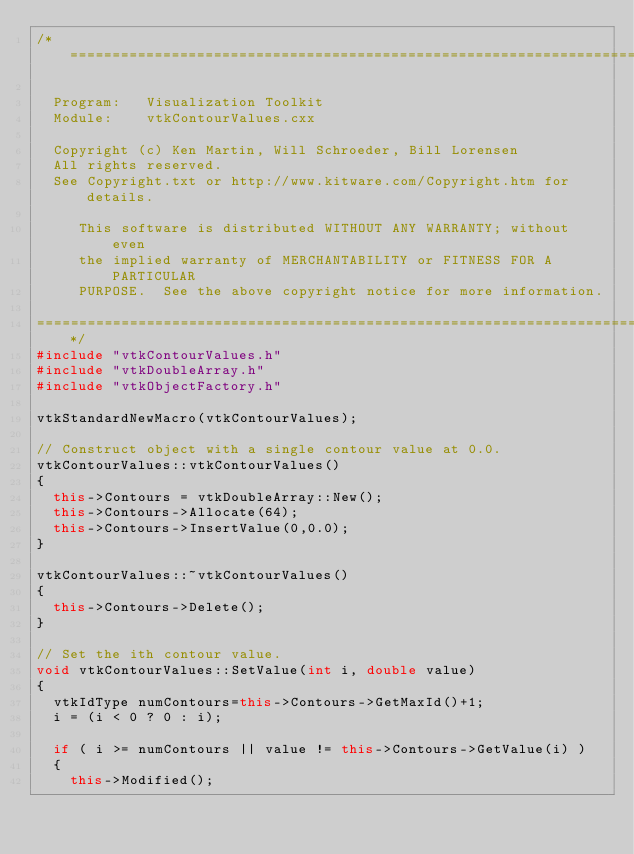Convert code to text. <code><loc_0><loc_0><loc_500><loc_500><_C++_>/*=========================================================================

  Program:   Visualization Toolkit
  Module:    vtkContourValues.cxx

  Copyright (c) Ken Martin, Will Schroeder, Bill Lorensen
  All rights reserved.
  See Copyright.txt or http://www.kitware.com/Copyright.htm for details.

     This software is distributed WITHOUT ANY WARRANTY; without even
     the implied warranty of MERCHANTABILITY or FITNESS FOR A PARTICULAR
     PURPOSE.  See the above copyright notice for more information.

=========================================================================*/
#include "vtkContourValues.h"
#include "vtkDoubleArray.h"
#include "vtkObjectFactory.h"

vtkStandardNewMacro(vtkContourValues);

// Construct object with a single contour value at 0.0.
vtkContourValues::vtkContourValues()
{
  this->Contours = vtkDoubleArray::New();
  this->Contours->Allocate(64);
  this->Contours->InsertValue(0,0.0);
}

vtkContourValues::~vtkContourValues()
{
  this->Contours->Delete();
}

// Set the ith contour value.
void vtkContourValues::SetValue(int i, double value)
{
  vtkIdType numContours=this->Contours->GetMaxId()+1;
  i = (i < 0 ? 0 : i);

  if ( i >= numContours || value != this->Contours->GetValue(i) )
  {
    this->Modified();</code> 